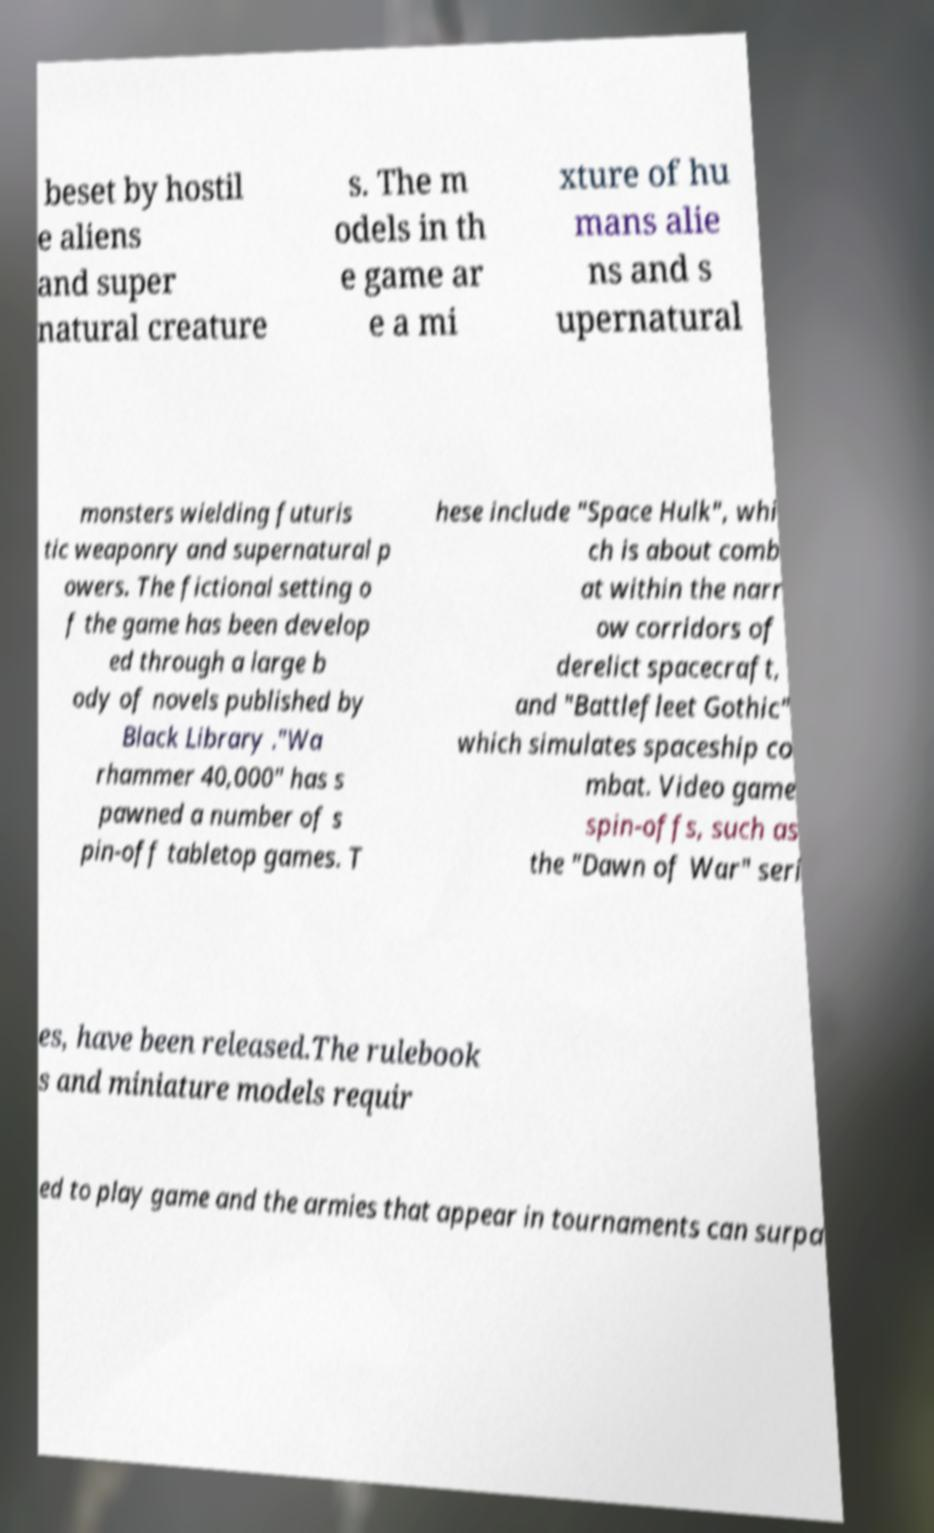Can you accurately transcribe the text from the provided image for me? beset by hostil e aliens and super natural creature s. The m odels in th e game ar e a mi xture of hu mans alie ns and s upernatural monsters wielding futuris tic weaponry and supernatural p owers. The fictional setting o f the game has been develop ed through a large b ody of novels published by Black Library ."Wa rhammer 40,000" has s pawned a number of s pin-off tabletop games. T hese include "Space Hulk", whi ch is about comb at within the narr ow corridors of derelict spacecraft, and "Battlefleet Gothic" which simulates spaceship co mbat. Video game spin-offs, such as the "Dawn of War" seri es, have been released.The rulebook s and miniature models requir ed to play game and the armies that appear in tournaments can surpa 